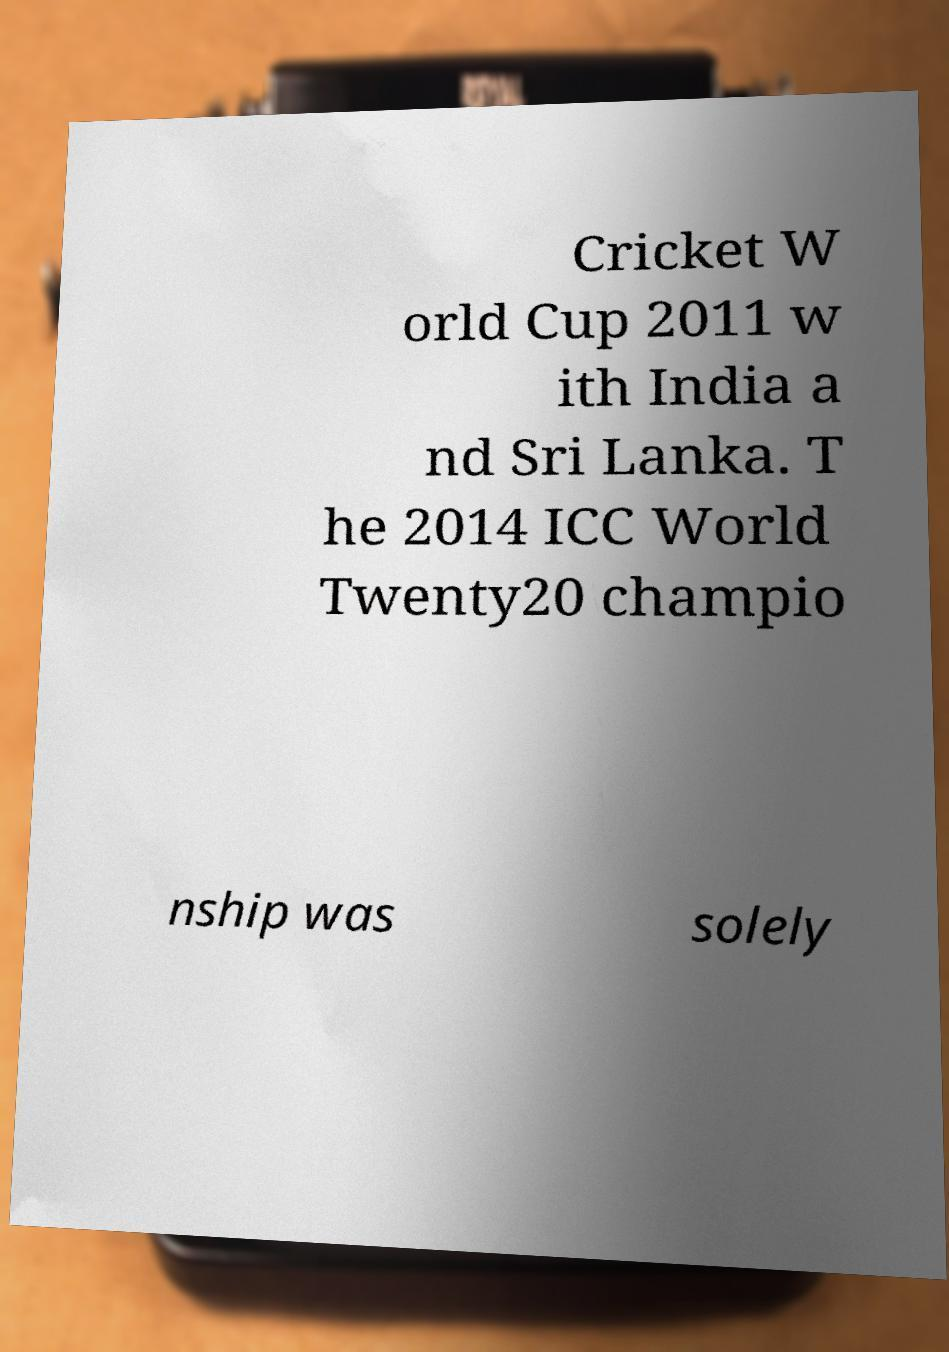Could you assist in decoding the text presented in this image and type it out clearly? Cricket W orld Cup 2011 w ith India a nd Sri Lanka. T he 2014 ICC World Twenty20 champio nship was solely 